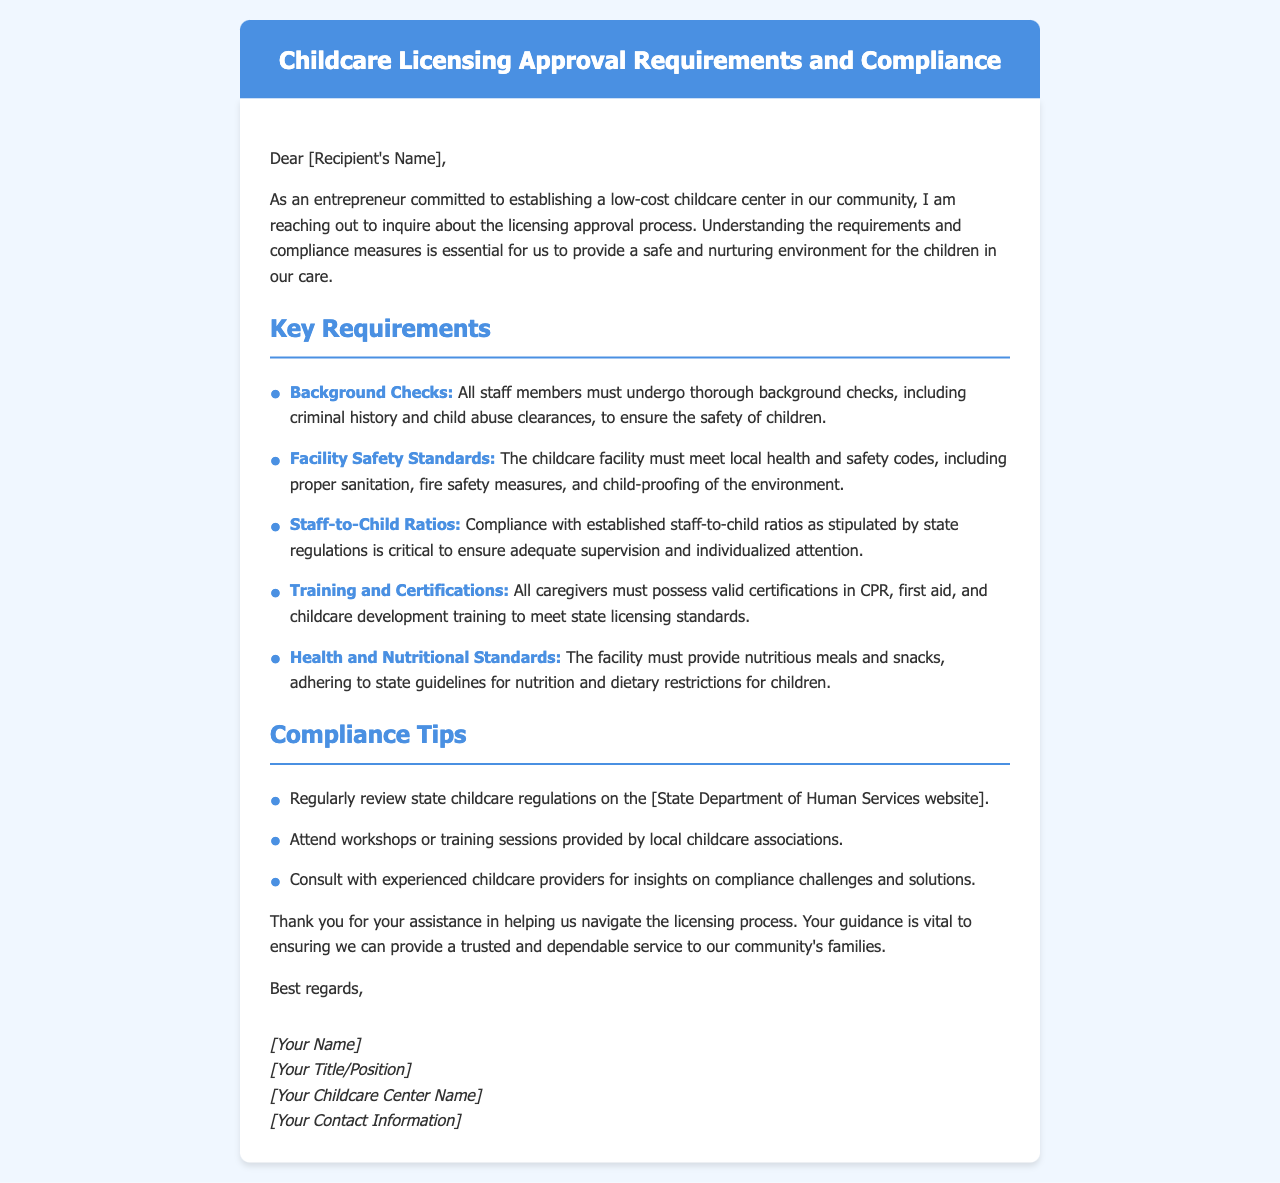What must all staff members undergo? The document states that all staff members must undergo thorough background checks to ensure child safety.
Answer: Background Checks What are the facility safety standards required? The document mentions that the childcare facility must meet local health and safety codes, including sanitation and fire safety measures.
Answer: Local health and safety codes What ratio is critical for supervision? The document specifies compliance with established staff-to-child ratios as critical for adequate supervision.
Answer: Staff-to-child ratios What certifications must caregivers possess? The document indicates that all caregivers must possess certifications in CPR, first aid, and childcare development training.
Answer: CPR, first aid, childcare development training What type of meals must the facility provide? The document states that the facility must provide nutritious meals and snacks adhering to state guidelines.
Answer: Nutritious meals and snacks What is a compliance tip related to state regulations? The document advises regularly reviewing state childcare regulations on the State Department of Human Services website.
Answer: Review state childcare regulations Who should caregivers consult for insights on compliance? The document suggests consulting with experienced childcare providers for insights on compliance challenges.
Answer: Experienced childcare providers What does the entrepreneur express gratitude for? The document expresses gratitude for assistance in navigating the licensing process.
Answer: Assistance in navigating the licensing process 